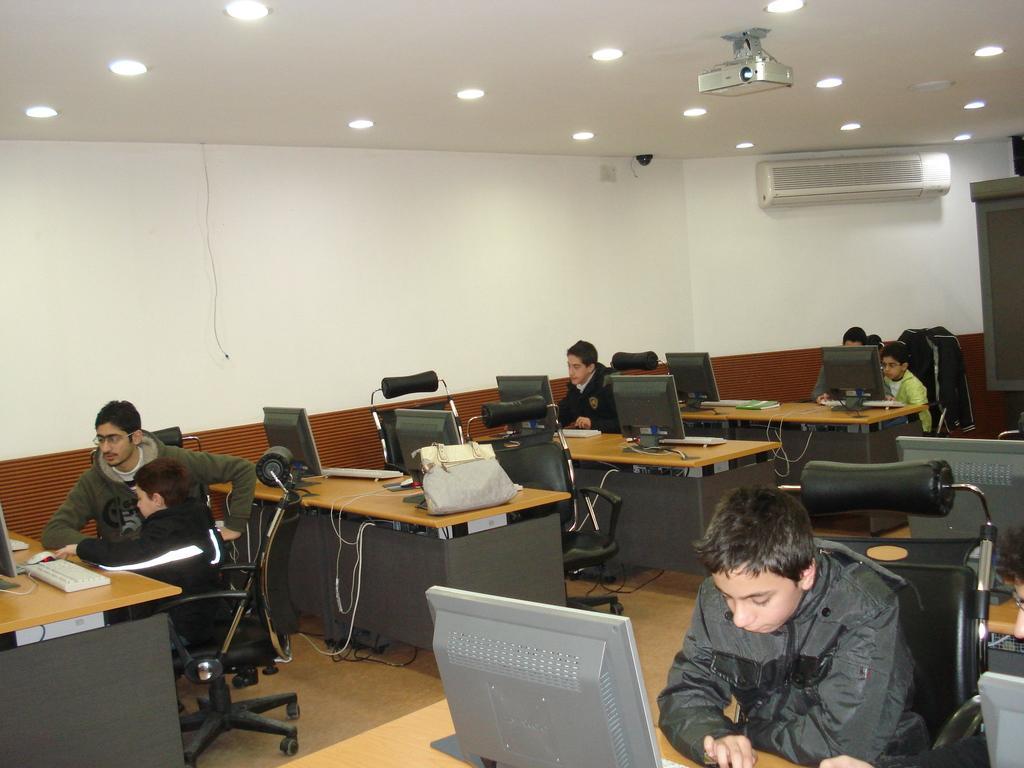Describe this image in one or two sentences. There are six people sitting on the chairs. This is a desk with a handbag on it. There are few computers on the desk. This is a keyboard. These are the ceiling lights attached to the rooftop. This is a projector attached to the rooftop. This is a air conditioner attached to the wall. 